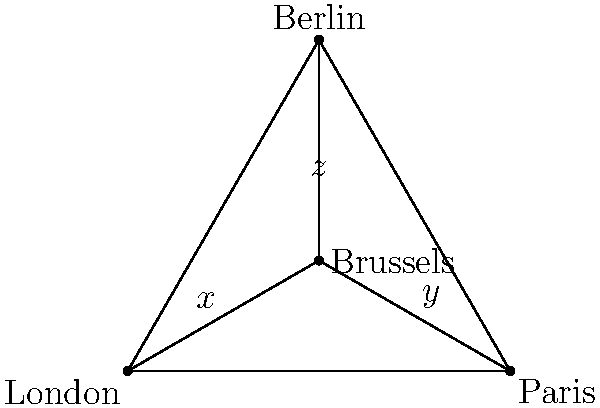A confidential map of flight paths between European capitals reveals a curious geometric pattern. The flight paths form a triangle with London, Paris, and Berlin at its vertices, while Brussels lies at the intersection of the three internal flight paths connecting these cities. If the angle formed by the London-Brussels-Paris flight path is $x°$, the Paris-Brussels-Berlin angle is $y°$, and the Berlin-Brussels-London angle is $z°$, what is the value of $x + y + z$? To solve this problem, we need to follow these steps:

1) First, recall that the sum of angles in a triangle is always 180°.

2) In this diagram, we have three triangles formed by Brussels and two of the other cities:
   - London-Brussels-Paris
   - Paris-Brussels-Berlin
   - Berlin-Brussels-London

3) Each of these triangles contains one of our unknown angles ($x$, $y$, or $z$) and two parts of the main triangle's angles.

4) Let's call the angles of the main triangle $α$ (at London), $β$ (at Paris), and $γ$ (at Berlin).

5) From the properties of triangles, we can write:
   $x + (part of β) + (part of α) = 180°$
   $y + (part of γ) + (part of β) = 180°$
   $z + (part of α) + (part of γ) = 180°$

6) If we add these three equations:
   $(x + y + z) + (α + β + γ) = 540°$

7) We know that $α + β + γ = 180°$ (sum of angles in the main triangle)

8) Substituting this in:
   $(x + y + z) + 180° = 540°$

9) Solving for $(x + y + z)$:
   $x + y + z = 540° - 180° = 360°$

Therefore, the sum of the three angles $x + y + z$ is always 360°, regardless of the specific shape of the triangle or position of Brussels within it.
Answer: 360° 